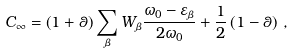Convert formula to latex. <formula><loc_0><loc_0><loc_500><loc_500>C _ { \infty } = \left ( 1 + \theta \right ) \sum _ { \beta } W _ { \beta } \frac { \omega _ { 0 } - \varepsilon _ { \beta } } { 2 \omega _ { 0 } } + \frac { 1 } { 2 } \left ( 1 - \theta \right ) \, ,</formula> 